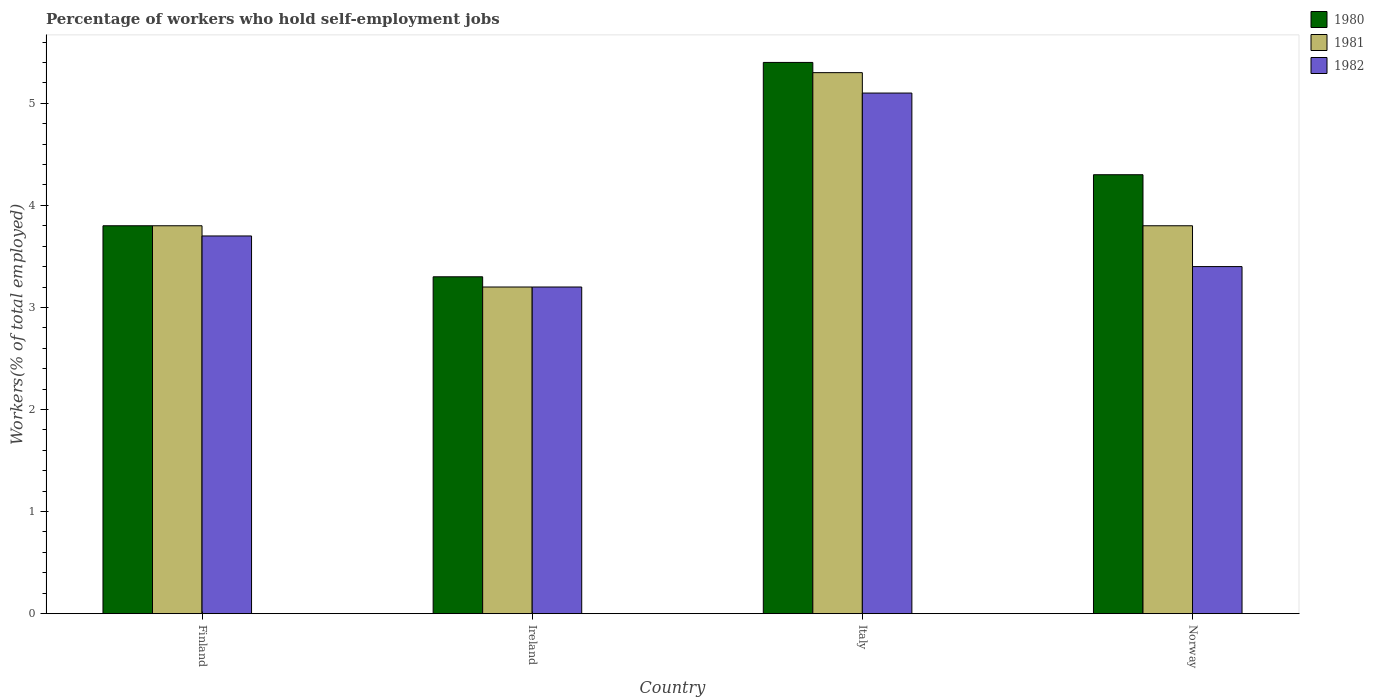How many different coloured bars are there?
Offer a very short reply. 3. Are the number of bars per tick equal to the number of legend labels?
Your answer should be compact. Yes. How many bars are there on the 4th tick from the right?
Your response must be concise. 3. What is the label of the 2nd group of bars from the left?
Your answer should be compact. Ireland. In how many cases, is the number of bars for a given country not equal to the number of legend labels?
Offer a terse response. 0. What is the percentage of self-employed workers in 1981 in Finland?
Your answer should be compact. 3.8. Across all countries, what is the maximum percentage of self-employed workers in 1982?
Give a very brief answer. 5.1. Across all countries, what is the minimum percentage of self-employed workers in 1981?
Your response must be concise. 3.2. In which country was the percentage of self-employed workers in 1982 minimum?
Give a very brief answer. Ireland. What is the total percentage of self-employed workers in 1981 in the graph?
Provide a succinct answer. 16.1. What is the difference between the percentage of self-employed workers in 1980 in Finland and that in Norway?
Provide a succinct answer. -0.5. What is the difference between the percentage of self-employed workers in 1981 in Finland and the percentage of self-employed workers in 1980 in Italy?
Your answer should be very brief. -1.6. What is the average percentage of self-employed workers in 1982 per country?
Offer a terse response. 3.85. What is the difference between the percentage of self-employed workers of/in 1981 and percentage of self-employed workers of/in 1980 in Norway?
Your answer should be very brief. -0.5. What is the ratio of the percentage of self-employed workers in 1982 in Italy to that in Norway?
Offer a terse response. 1.5. Is the difference between the percentage of self-employed workers in 1981 in Finland and Norway greater than the difference between the percentage of self-employed workers in 1980 in Finland and Norway?
Offer a very short reply. Yes. What is the difference between the highest and the second highest percentage of self-employed workers in 1982?
Your answer should be compact. -0.3. What is the difference between the highest and the lowest percentage of self-employed workers in 1980?
Give a very brief answer. 2.1. Is the sum of the percentage of self-employed workers in 1980 in Ireland and Italy greater than the maximum percentage of self-employed workers in 1981 across all countries?
Ensure brevity in your answer.  Yes. What does the 1st bar from the left in Norway represents?
Offer a very short reply. 1980. What does the 1st bar from the right in Ireland represents?
Offer a terse response. 1982. How many bars are there?
Provide a short and direct response. 12. How many countries are there in the graph?
Provide a short and direct response. 4. What is the difference between two consecutive major ticks on the Y-axis?
Your answer should be very brief. 1. Are the values on the major ticks of Y-axis written in scientific E-notation?
Provide a succinct answer. No. Where does the legend appear in the graph?
Ensure brevity in your answer.  Top right. What is the title of the graph?
Your response must be concise. Percentage of workers who hold self-employment jobs. What is the label or title of the Y-axis?
Provide a succinct answer. Workers(% of total employed). What is the Workers(% of total employed) of 1980 in Finland?
Your answer should be very brief. 3.8. What is the Workers(% of total employed) in 1981 in Finland?
Your answer should be very brief. 3.8. What is the Workers(% of total employed) in 1982 in Finland?
Keep it short and to the point. 3.7. What is the Workers(% of total employed) in 1980 in Ireland?
Make the answer very short. 3.3. What is the Workers(% of total employed) in 1981 in Ireland?
Your answer should be very brief. 3.2. What is the Workers(% of total employed) in 1982 in Ireland?
Offer a very short reply. 3.2. What is the Workers(% of total employed) of 1980 in Italy?
Keep it short and to the point. 5.4. What is the Workers(% of total employed) in 1981 in Italy?
Provide a short and direct response. 5.3. What is the Workers(% of total employed) of 1982 in Italy?
Give a very brief answer. 5.1. What is the Workers(% of total employed) of 1980 in Norway?
Offer a terse response. 4.3. What is the Workers(% of total employed) of 1981 in Norway?
Ensure brevity in your answer.  3.8. What is the Workers(% of total employed) of 1982 in Norway?
Offer a very short reply. 3.4. Across all countries, what is the maximum Workers(% of total employed) in 1980?
Your answer should be compact. 5.4. Across all countries, what is the maximum Workers(% of total employed) of 1981?
Offer a terse response. 5.3. Across all countries, what is the maximum Workers(% of total employed) in 1982?
Offer a terse response. 5.1. Across all countries, what is the minimum Workers(% of total employed) of 1980?
Your answer should be compact. 3.3. Across all countries, what is the minimum Workers(% of total employed) in 1981?
Your response must be concise. 3.2. Across all countries, what is the minimum Workers(% of total employed) of 1982?
Keep it short and to the point. 3.2. What is the difference between the Workers(% of total employed) in 1981 in Finland and that in Ireland?
Offer a very short reply. 0.6. What is the difference between the Workers(% of total employed) of 1982 in Finland and that in Italy?
Keep it short and to the point. -1.4. What is the difference between the Workers(% of total employed) of 1980 in Finland and that in Norway?
Offer a very short reply. -0.5. What is the difference between the Workers(% of total employed) in 1981 in Finland and that in Norway?
Make the answer very short. 0. What is the difference between the Workers(% of total employed) in 1980 in Ireland and that in Italy?
Your answer should be compact. -2.1. What is the difference between the Workers(% of total employed) of 1981 in Ireland and that in Italy?
Ensure brevity in your answer.  -2.1. What is the difference between the Workers(% of total employed) in 1982 in Ireland and that in Italy?
Offer a terse response. -1.9. What is the difference between the Workers(% of total employed) in 1981 in Ireland and that in Norway?
Your answer should be very brief. -0.6. What is the difference between the Workers(% of total employed) of 1982 in Ireland and that in Norway?
Your response must be concise. -0.2. What is the difference between the Workers(% of total employed) in 1980 in Italy and that in Norway?
Your answer should be compact. 1.1. What is the difference between the Workers(% of total employed) of 1980 in Finland and the Workers(% of total employed) of 1981 in Ireland?
Make the answer very short. 0.6. What is the difference between the Workers(% of total employed) in 1980 in Finland and the Workers(% of total employed) in 1981 in Italy?
Make the answer very short. -1.5. What is the difference between the Workers(% of total employed) in 1980 in Finland and the Workers(% of total employed) in 1982 in Norway?
Offer a very short reply. 0.4. What is the difference between the Workers(% of total employed) in 1981 in Ireland and the Workers(% of total employed) in 1982 in Italy?
Offer a terse response. -1.9. What is the difference between the Workers(% of total employed) of 1981 in Ireland and the Workers(% of total employed) of 1982 in Norway?
Your answer should be very brief. -0.2. What is the difference between the Workers(% of total employed) in 1980 in Italy and the Workers(% of total employed) in 1981 in Norway?
Keep it short and to the point. 1.6. What is the average Workers(% of total employed) of 1980 per country?
Make the answer very short. 4.2. What is the average Workers(% of total employed) of 1981 per country?
Offer a very short reply. 4.03. What is the average Workers(% of total employed) in 1982 per country?
Give a very brief answer. 3.85. What is the difference between the Workers(% of total employed) in 1980 and Workers(% of total employed) in 1981 in Finland?
Keep it short and to the point. 0. What is the difference between the Workers(% of total employed) of 1980 and Workers(% of total employed) of 1982 in Finland?
Offer a very short reply. 0.1. What is the difference between the Workers(% of total employed) of 1981 and Workers(% of total employed) of 1982 in Ireland?
Your answer should be very brief. 0. What is the difference between the Workers(% of total employed) in 1980 and Workers(% of total employed) in 1982 in Italy?
Your response must be concise. 0.3. What is the difference between the Workers(% of total employed) of 1981 and Workers(% of total employed) of 1982 in Italy?
Give a very brief answer. 0.2. What is the difference between the Workers(% of total employed) in 1981 and Workers(% of total employed) in 1982 in Norway?
Offer a very short reply. 0.4. What is the ratio of the Workers(% of total employed) of 1980 in Finland to that in Ireland?
Keep it short and to the point. 1.15. What is the ratio of the Workers(% of total employed) in 1981 in Finland to that in Ireland?
Your answer should be very brief. 1.19. What is the ratio of the Workers(% of total employed) of 1982 in Finland to that in Ireland?
Your answer should be very brief. 1.16. What is the ratio of the Workers(% of total employed) of 1980 in Finland to that in Italy?
Offer a terse response. 0.7. What is the ratio of the Workers(% of total employed) of 1981 in Finland to that in Italy?
Provide a short and direct response. 0.72. What is the ratio of the Workers(% of total employed) in 1982 in Finland to that in Italy?
Make the answer very short. 0.73. What is the ratio of the Workers(% of total employed) in 1980 in Finland to that in Norway?
Your response must be concise. 0.88. What is the ratio of the Workers(% of total employed) in 1981 in Finland to that in Norway?
Keep it short and to the point. 1. What is the ratio of the Workers(% of total employed) of 1982 in Finland to that in Norway?
Keep it short and to the point. 1.09. What is the ratio of the Workers(% of total employed) of 1980 in Ireland to that in Italy?
Give a very brief answer. 0.61. What is the ratio of the Workers(% of total employed) of 1981 in Ireland to that in Italy?
Offer a terse response. 0.6. What is the ratio of the Workers(% of total employed) of 1982 in Ireland to that in Italy?
Offer a very short reply. 0.63. What is the ratio of the Workers(% of total employed) of 1980 in Ireland to that in Norway?
Give a very brief answer. 0.77. What is the ratio of the Workers(% of total employed) of 1981 in Ireland to that in Norway?
Your answer should be very brief. 0.84. What is the ratio of the Workers(% of total employed) in 1982 in Ireland to that in Norway?
Keep it short and to the point. 0.94. What is the ratio of the Workers(% of total employed) of 1980 in Italy to that in Norway?
Offer a very short reply. 1.26. What is the ratio of the Workers(% of total employed) in 1981 in Italy to that in Norway?
Your answer should be very brief. 1.39. What is the difference between the highest and the second highest Workers(% of total employed) in 1980?
Your answer should be very brief. 1.1. What is the difference between the highest and the lowest Workers(% of total employed) of 1980?
Your response must be concise. 2.1. 